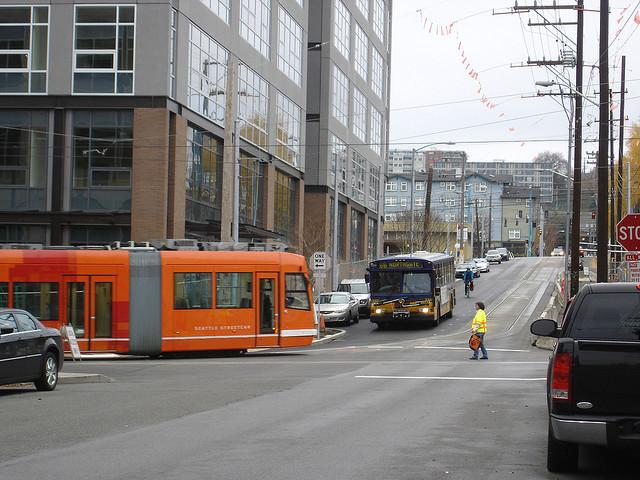What is the reason for the woman in yellow standing in the street here? Please explain your reasoning. road construction. The reason is road construction. 